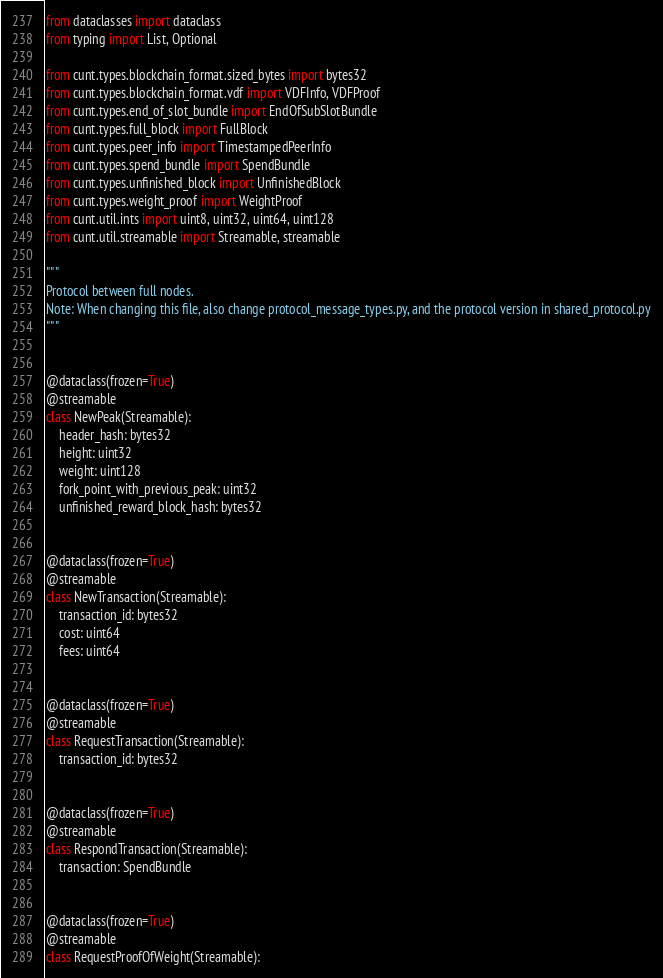<code> <loc_0><loc_0><loc_500><loc_500><_Python_>from dataclasses import dataclass
from typing import List, Optional

from cunt.types.blockchain_format.sized_bytes import bytes32
from cunt.types.blockchain_format.vdf import VDFInfo, VDFProof
from cunt.types.end_of_slot_bundle import EndOfSubSlotBundle
from cunt.types.full_block import FullBlock
from cunt.types.peer_info import TimestampedPeerInfo
from cunt.types.spend_bundle import SpendBundle
from cunt.types.unfinished_block import UnfinishedBlock
from cunt.types.weight_proof import WeightProof
from cunt.util.ints import uint8, uint32, uint64, uint128
from cunt.util.streamable import Streamable, streamable

"""
Protocol between full nodes.
Note: When changing this file, also change protocol_message_types.py, and the protocol version in shared_protocol.py
"""


@dataclass(frozen=True)
@streamable
class NewPeak(Streamable):
    header_hash: bytes32
    height: uint32
    weight: uint128
    fork_point_with_previous_peak: uint32
    unfinished_reward_block_hash: bytes32


@dataclass(frozen=True)
@streamable
class NewTransaction(Streamable):
    transaction_id: bytes32
    cost: uint64
    fees: uint64


@dataclass(frozen=True)
@streamable
class RequestTransaction(Streamable):
    transaction_id: bytes32


@dataclass(frozen=True)
@streamable
class RespondTransaction(Streamable):
    transaction: SpendBundle


@dataclass(frozen=True)
@streamable
class RequestProofOfWeight(Streamable):</code> 